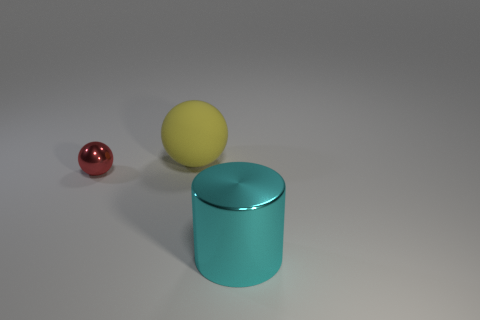Subtract all yellow spheres. Subtract all red cylinders. How many spheres are left? 1 Add 2 matte things. How many objects exist? 5 Subtract all spheres. How many objects are left? 1 Subtract 0 gray spheres. How many objects are left? 3 Subtract all big yellow objects. Subtract all yellow rubber things. How many objects are left? 1 Add 1 large rubber balls. How many large rubber balls are left? 2 Add 1 cyan objects. How many cyan objects exist? 2 